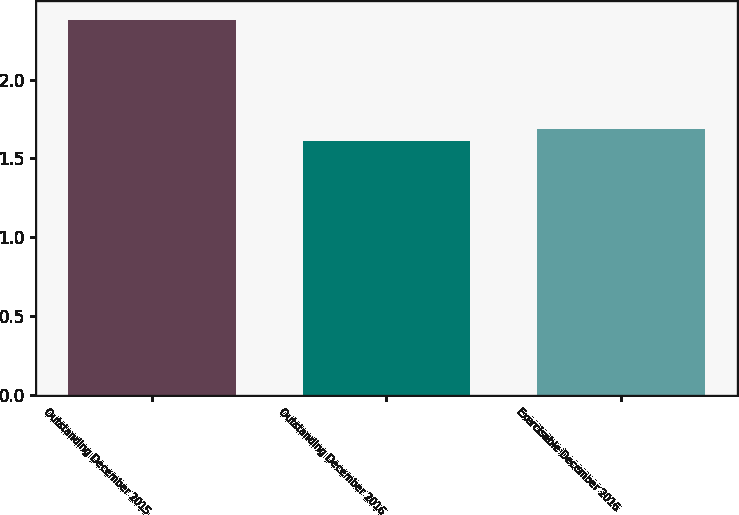Convert chart to OTSL. <chart><loc_0><loc_0><loc_500><loc_500><bar_chart><fcel>Outstanding December 2015<fcel>Outstanding December 2016<fcel>Exercisable December 2016<nl><fcel>2.38<fcel>1.61<fcel>1.69<nl></chart> 